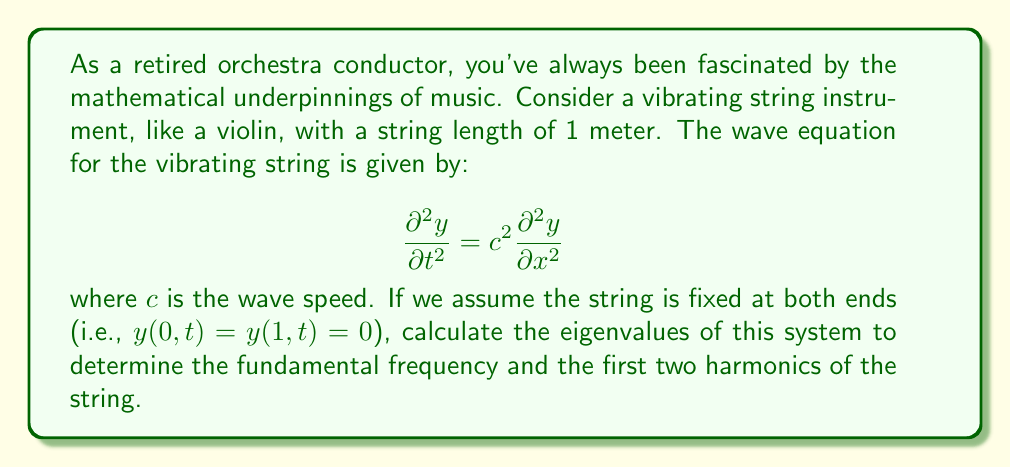Teach me how to tackle this problem. To solve this problem, we'll follow these steps:

1) First, we need to separate variables. Let $y(x,t) = X(x)T(t)$.

2) Substituting this into the wave equation:

   $$X(x)\frac{d^2T}{dt^2} = c^2T(t)\frac{d^2X}{dx^2}$$

3) Dividing both sides by $c^2X(x)T(t)$:

   $$\frac{1}{c^2T}\frac{d^2T}{dt^2} = \frac{1}{X}\frac{d^2X}{dx^2}$$

4) Since the left side depends only on $t$ and the right side only on $x$, both must equal a constant. Let's call this constant $-\lambda^2$:

   $$\frac{1}{c^2T}\frac{d^2T}{dt^2} = -\lambda^2 = \frac{1}{X}\frac{d^2X}{dx^2}$$

5) This gives us two ordinary differential equations:

   $$\frac{d^2T}{dt^2} + c^2\lambda^2T = 0$$
   $$\frac{d^2X}{dx^2} + \lambda^2X = 0$$

6) The equation for $X$ with boundary conditions $X(0) = X(1) = 0$ is a Sturm-Liouville problem. Its solutions are:

   $$X_n(x) = \sin(n\pi x), \quad n = 1, 2, 3, ...$$

7) The corresponding eigenvalues are:

   $$\lambda_n = n\pi, \quad n = 1, 2, 3, ...$$

8) The frequencies of vibration are given by:

   $$f_n = \frac{c\lambda_n}{2\pi} = \frac{nc}{2}, \quad n = 1, 2, 3, ...$$

9) The fundamental frequency (n=1) and the first two harmonics (n=2 and n=3) are:

   Fundamental: $f_1 = \frac{c}{2}$
   First harmonic: $f_2 = c$
   Second harmonic: $f_3 = \frac{3c}{2}$

Note that the wave speed $c$ depends on the tension and linear density of the string.
Answer: The eigenvalues are $\lambda_n = n\pi$ for $n = 1, 2, 3, ...$

The frequencies are $f_n = \frac{nc}{2}$ for $n = 1, 2, 3, ...$

Fundamental frequency: $f_1 = \frac{c}{2}$
First harmonic: $f_2 = c$
Second harmonic: $f_3 = \frac{3c}{2}$ 